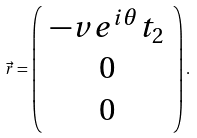Convert formula to latex. <formula><loc_0><loc_0><loc_500><loc_500>\vec { r } = \left ( \begin{array} { c } - v e ^ { i \theta } t _ { 2 } \\ 0 \\ 0 \end{array} \right ) .</formula> 